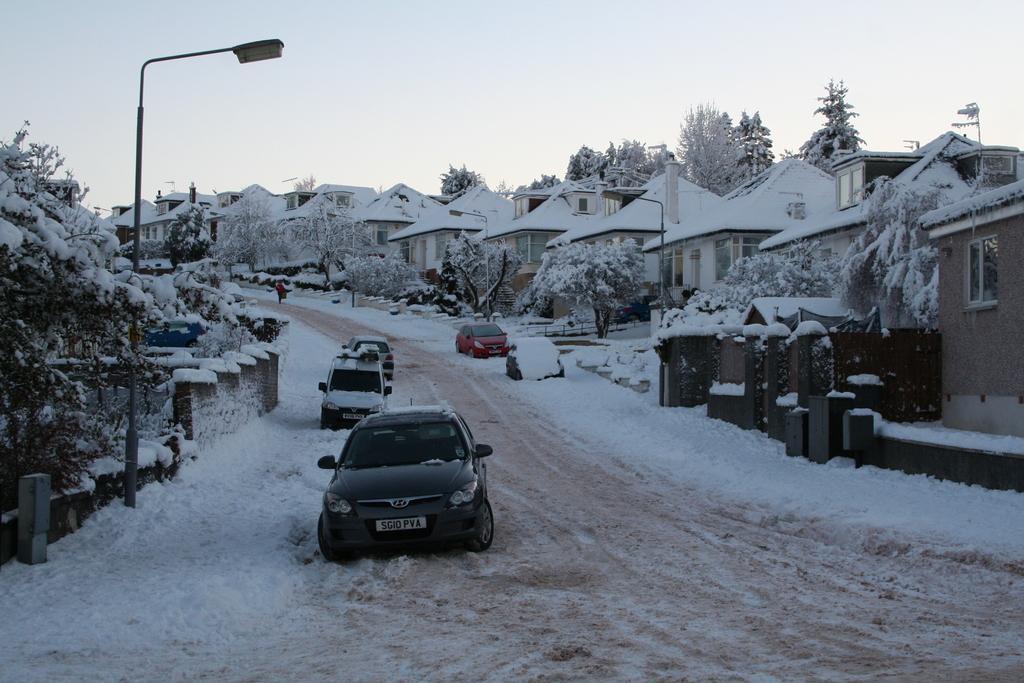In one or two sentences, can you explain what this image depicts? In this picture I can see some cars which are parked near to the road, beside the road I can see the street lights, trees, fencing and snow. On the right I can see many buildings. At the top I can see the sky. 